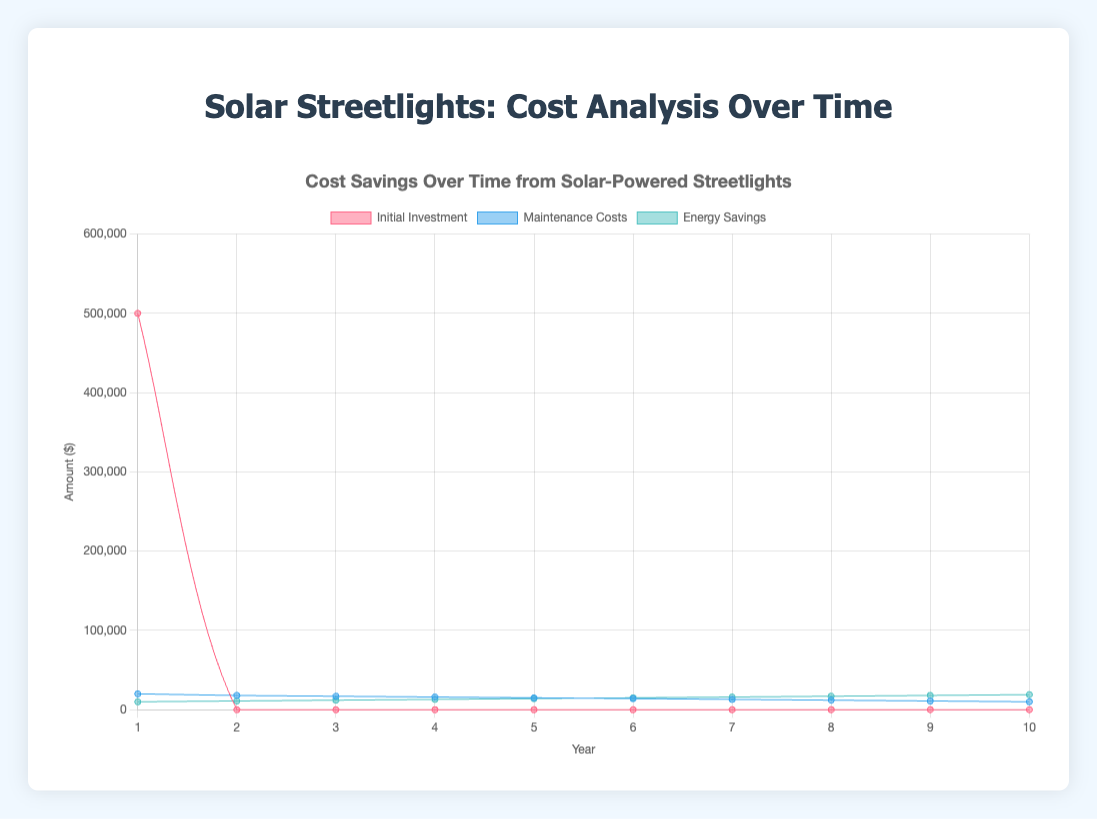What is the title of the chart? The title of the chart is displayed at the top and summarizes what the chart is about.
Answer: Cost Savings Over Time from Solar-Powered Streetlights What does the x-axis represent? The labels on the x-axis show years from 1 to 10, indicating the timespan over which the data is measured.
Answer: Years What does the y-axis represent? The y-axis is labeled with 'Amount ($)', showing the cost or savings in dollars.
Answer: Amount ($) In which year was the initial investment made? The 'Initial Investment' line is only non-zero in year 1, indicating the upfront investment.
Answer: Year 1 How much were the maintenance costs in year 4? The maintenance costs for each year can be read from the 'Maintenance Costs' line. In year 4, the maintenance cost is $16,000.
Answer: $16,000 By how much did the energy savings increase from year 1 to year 5? The energy savings in year 1 are $10,000 and in year 5 are $14,000. The increase can be calculated as $14,000 - $10,000 = $4,000.
Answer: $4,000 Which year had the lowest maintenance cost and what was it? The lowest point on the 'Maintenance Costs' line shows the year with the lowest maintenance costs, which is year 10 with a cost of $10,000.
Answer: Year 10, $10,000 Are the energy savings greater than the maintenance costs in year 7? Comparing values in year 7: Energy Savings ($16,000) vs. Maintenance Costs ($13,000). Energy Savings are greater.
Answer: Yes What is the difference between initial investment and total maintenance costs by year 10? Initial investment is $500,000. Sum of maintenance costs: $20,000 + $18,000 + $17,000 + $16,000 + $15,000 + $14,000 + $13,000 + $12,000 + $11,000 + $10,000 = $146,000. Difference: $500,000 - $146,000 = $354,000.
Answer: $354,000 What trend can be observed in maintenance costs over time? The 'Maintenance Costs' line decreases each year, indicating a downward trend in maintenance costs over the 10 years.
Answer: Decreases 